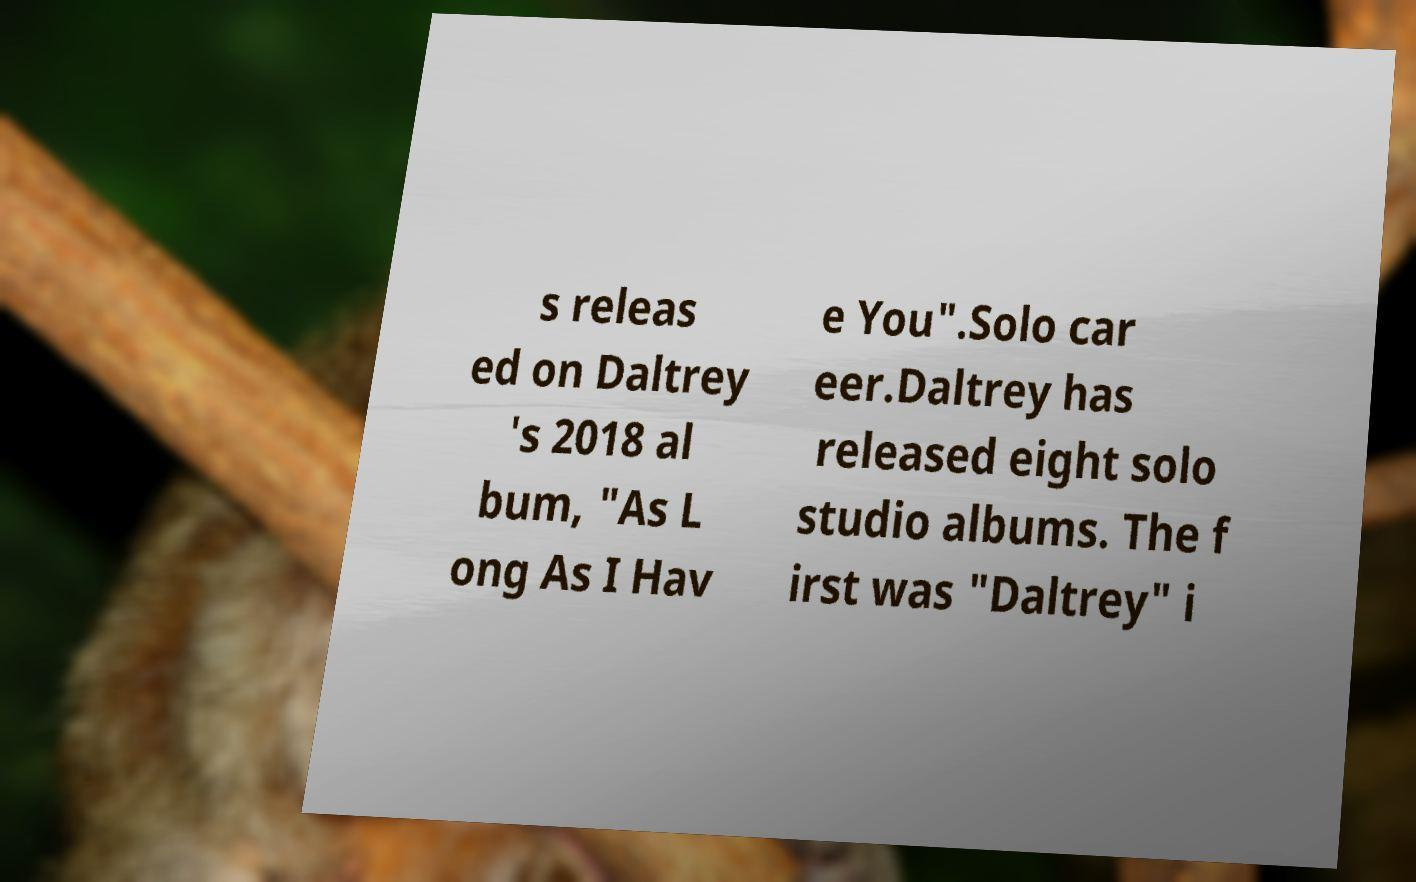There's text embedded in this image that I need extracted. Can you transcribe it verbatim? s releas ed on Daltrey 's 2018 al bum, "As L ong As I Hav e You".Solo car eer.Daltrey has released eight solo studio albums. The f irst was "Daltrey" i 